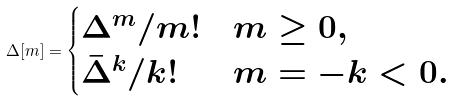Convert formula to latex. <formula><loc_0><loc_0><loc_500><loc_500>\Delta [ m ] = \begin{cases} \Delta ^ { m } / m ! & m \geq 0 , \\ \bar { \Delta } ^ { k } / k ! & m = - k < 0 . \end{cases}</formula> 